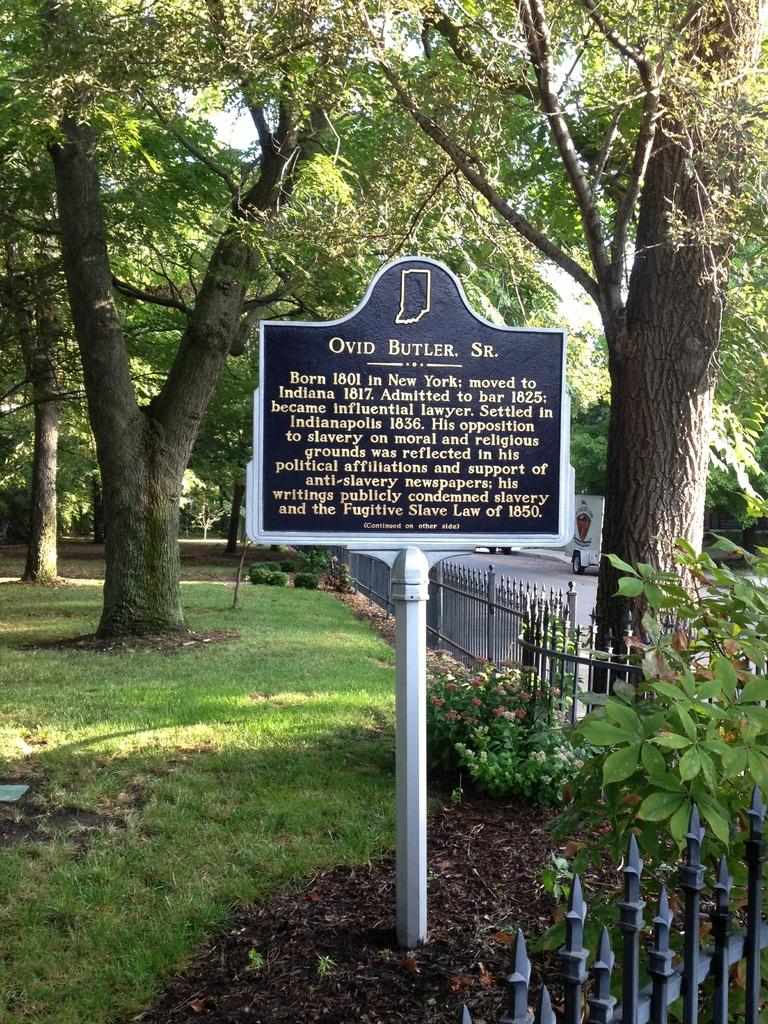What is on the board that is visible in the image? There is a board with words written on it in the image. What type of natural environment is present in the image? There are trees and grass in the image. What is on the right side of the image? There is a road on the right side of the image. What is happening on the road in the image? Vehicles are moving on the road. How many dolls are sitting on the road in the image? There are no dolls present in the image; it features a board with words, trees, grass, a road, and moving vehicles. 